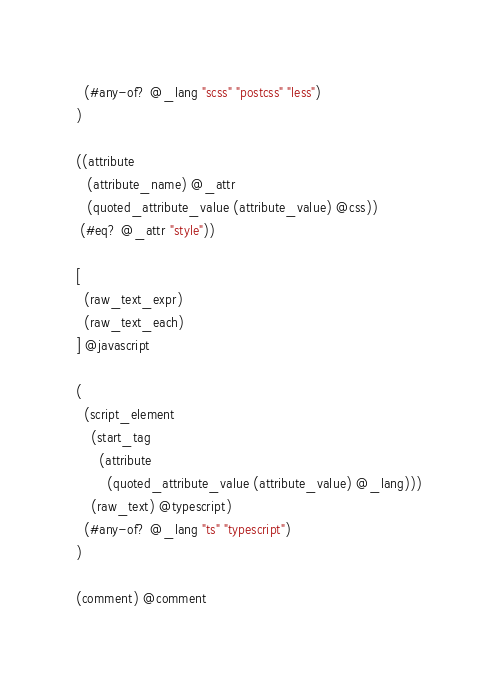<code> <loc_0><loc_0><loc_500><loc_500><_Scheme_>  (#any-of? @_lang "scss" "postcss" "less")
)

((attribute
   (attribute_name) @_attr
   (quoted_attribute_value (attribute_value) @css))
 (#eq? @_attr "style"))

[
  (raw_text_expr)
  (raw_text_each)
] @javascript

(
  (script_element
    (start_tag
      (attribute
        (quoted_attribute_value (attribute_value) @_lang)))
    (raw_text) @typescript)
  (#any-of? @_lang "ts" "typescript")
)

(comment) @comment
</code> 